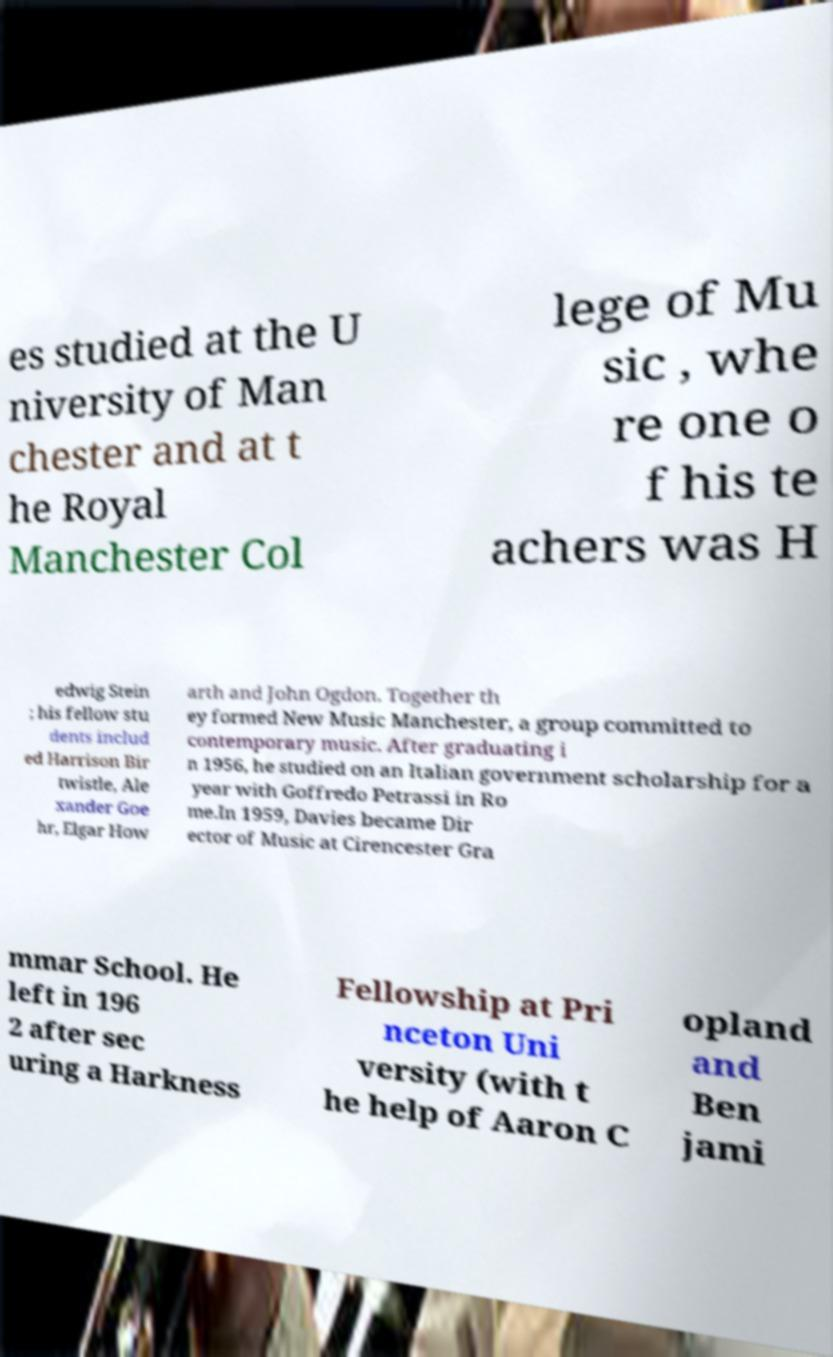Could you assist in decoding the text presented in this image and type it out clearly? es studied at the U niversity of Man chester and at t he Royal Manchester Col lege of Mu sic , whe re one o f his te achers was H edwig Stein ; his fellow stu dents includ ed Harrison Bir twistle, Ale xander Goe hr, Elgar How arth and John Ogdon. Together th ey formed New Music Manchester, a group committed to contemporary music. After graduating i n 1956, he studied on an Italian government scholarship for a year with Goffredo Petrassi in Ro me.In 1959, Davies became Dir ector of Music at Cirencester Gra mmar School. He left in 196 2 after sec uring a Harkness Fellowship at Pri nceton Uni versity (with t he help of Aaron C opland and Ben jami 